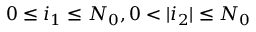Convert formula to latex. <formula><loc_0><loc_0><loc_500><loc_500>0 \leq i _ { 1 } \leq N _ { 0 } , 0 < | i _ { 2 } | \leq N _ { 0 }</formula> 